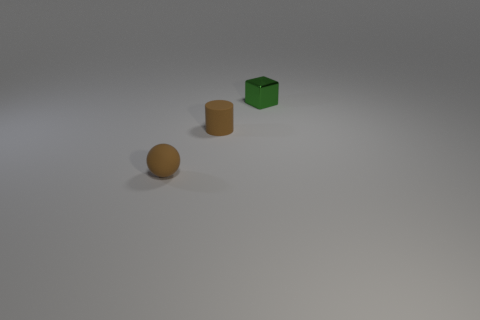Add 1 small brown rubber spheres. How many objects exist? 4 Subtract all cylinders. How many objects are left? 2 Subtract all tiny purple rubber objects. Subtract all small cylinders. How many objects are left? 2 Add 2 brown rubber objects. How many brown rubber objects are left? 4 Add 3 small shiny objects. How many small shiny objects exist? 4 Subtract 1 brown cylinders. How many objects are left? 2 